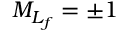<formula> <loc_0><loc_0><loc_500><loc_500>{ M } _ { L _ { f } } = \pm 1</formula> 